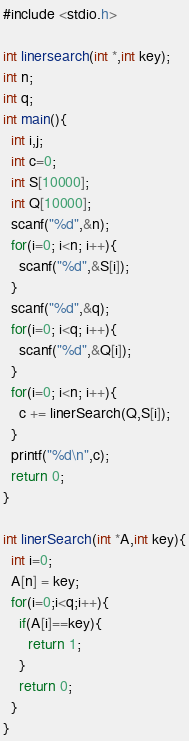<code> <loc_0><loc_0><loc_500><loc_500><_Java_>#include <stdio.h>

int linersearch(int *,int key);
int n;
int q;
int main(){
  int i,j;
  int c=0;
  int S[10000];
  int Q[10000];
  scanf("%d",&n);
  for(i=0; i<n; i++){
    scanf("%d",&S[i]);
  }
  scanf("%d",&q);
  for(i=0; i<q; i++){
    scanf("%d",&Q[i]);
  }
  for(i=0; i<n; i++){
    c += linerSearch(Q,S[i]);
  }
  printf("%d\n",c);
  return 0;
}

int linerSearch(int *A,int key){
  int i=0;
  A[n] = key;
  for(i=0;i<q;i++){
    if(A[i]==key){
      return 1;
    }
    return 0;
  }
}


</code> 